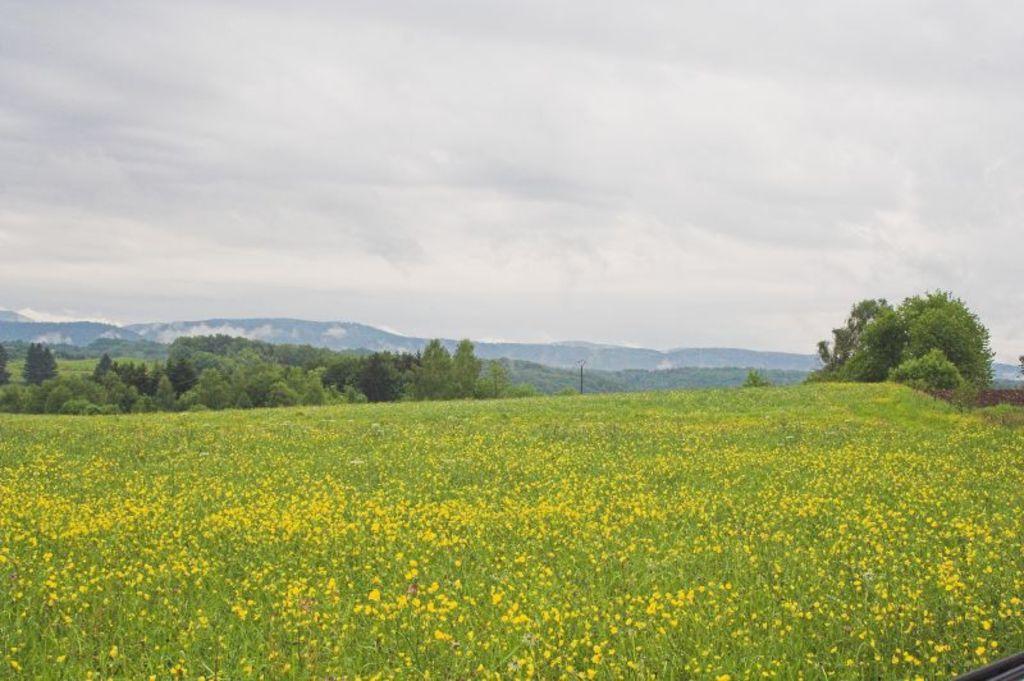Can you describe this image briefly? This image is taken outdoors. At the top of the image there is a sky with clouds. In the background there are a few hills. In the middle of the image there are many plants and trees. At the bottom of the image there are many plants with yellow colored flowers. 